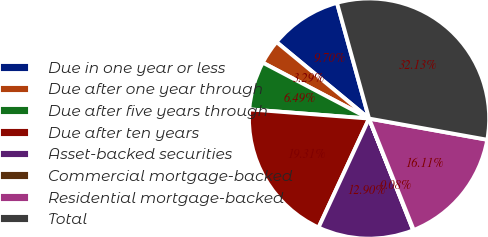Convert chart to OTSL. <chart><loc_0><loc_0><loc_500><loc_500><pie_chart><fcel>Due in one year or less<fcel>Due after one year through<fcel>Due after five years through<fcel>Due after ten years<fcel>Asset-backed securities<fcel>Commercial mortgage-backed<fcel>Residential mortgage-backed<fcel>Total<nl><fcel>9.7%<fcel>3.29%<fcel>6.49%<fcel>19.31%<fcel>12.9%<fcel>0.08%<fcel>16.11%<fcel>32.13%<nl></chart> 